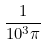Convert formula to latex. <formula><loc_0><loc_0><loc_500><loc_500>\frac { 1 } { 1 0 ^ { 3 } \pi }</formula> 